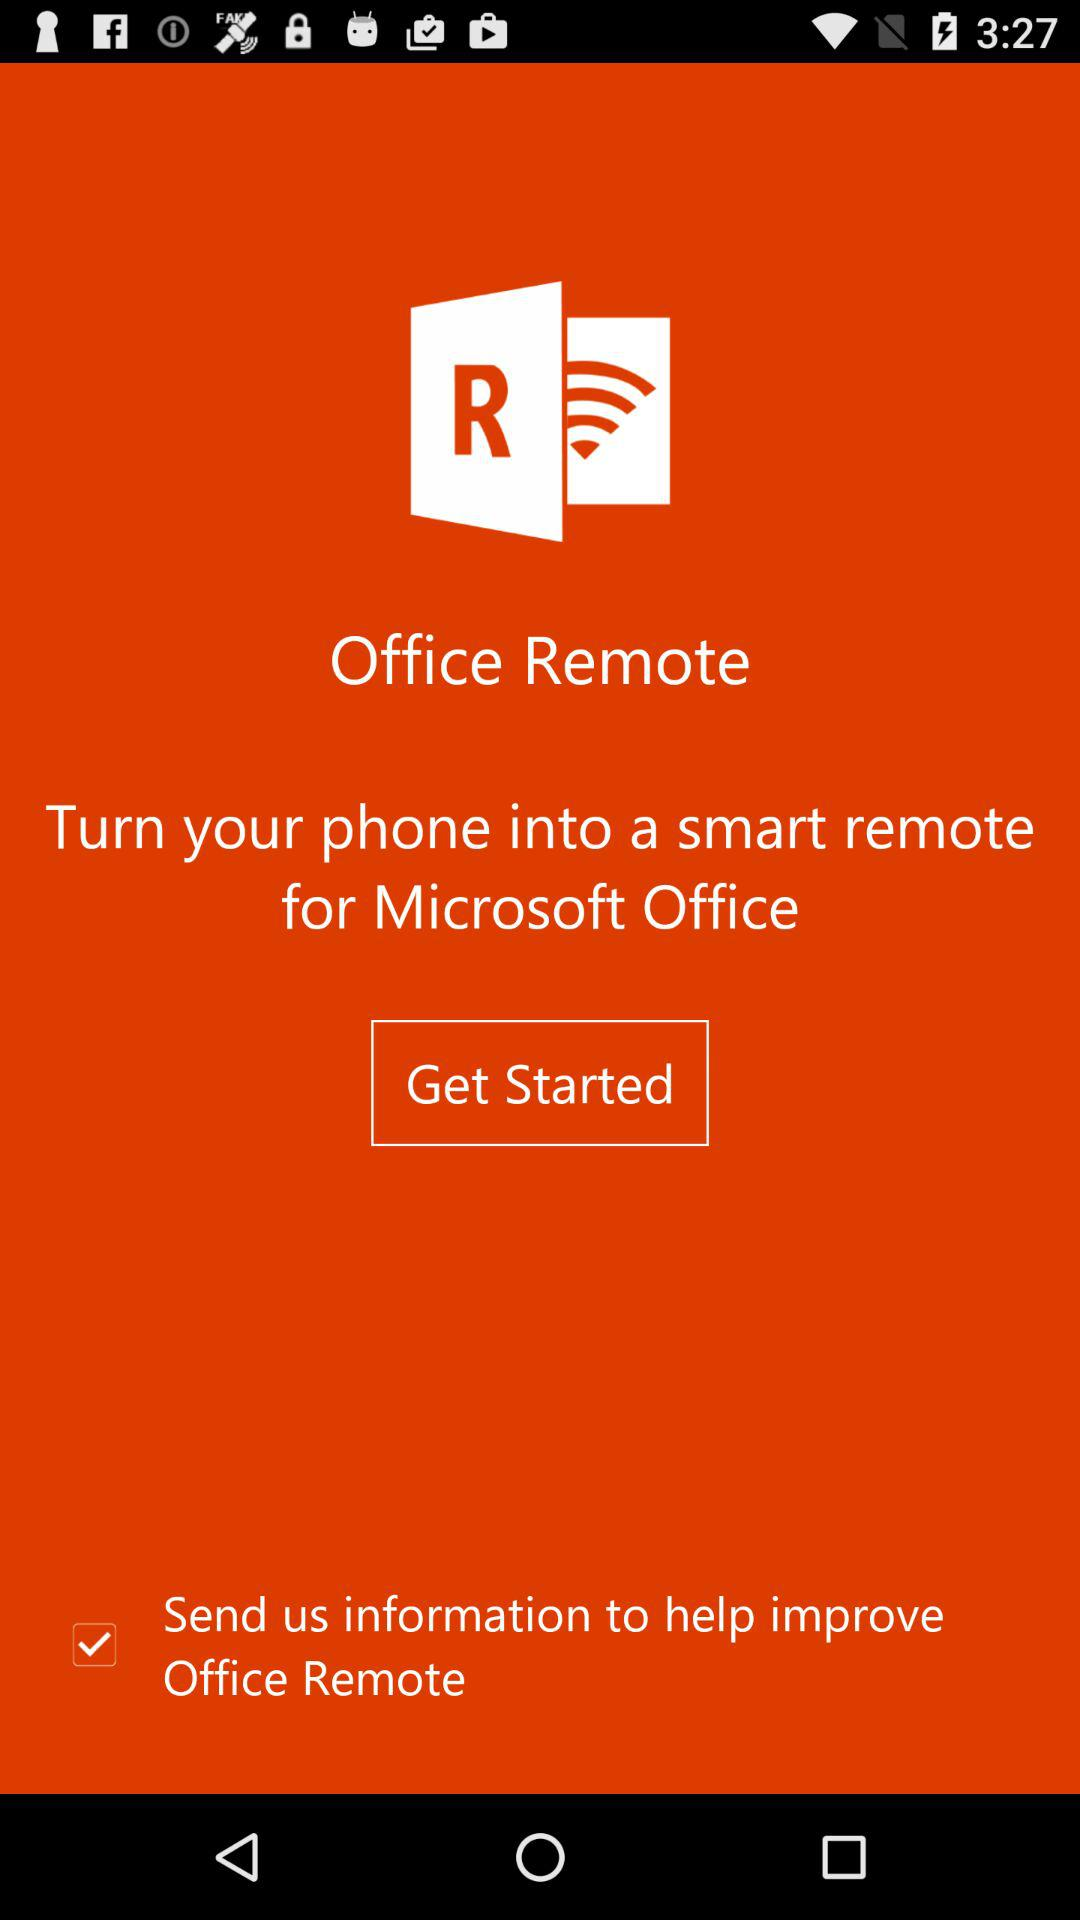What is the status of the "Send us information"? The status is on. 